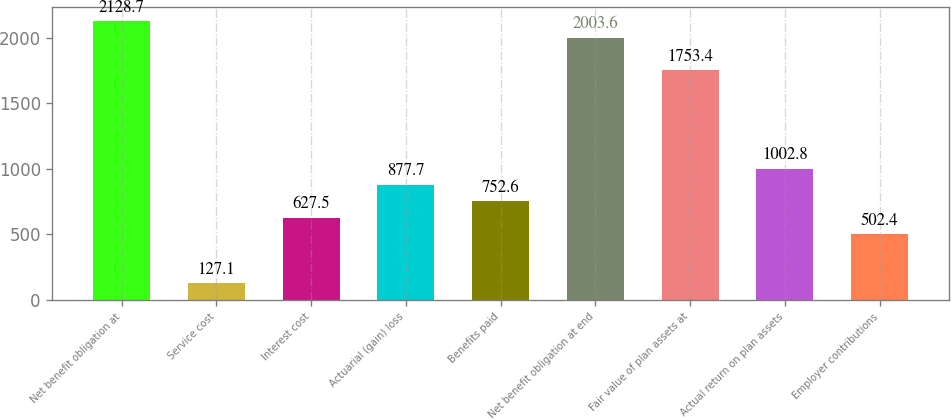<chart> <loc_0><loc_0><loc_500><loc_500><bar_chart><fcel>Net benefit obligation at<fcel>Service cost<fcel>Interest cost<fcel>Actuarial (gain) loss<fcel>Benefits paid<fcel>Net benefit obligation at end<fcel>Fair value of plan assets at<fcel>Actual return on plan assets<fcel>Employer contributions<nl><fcel>2128.7<fcel>127.1<fcel>627.5<fcel>877.7<fcel>752.6<fcel>2003.6<fcel>1753.4<fcel>1002.8<fcel>502.4<nl></chart> 